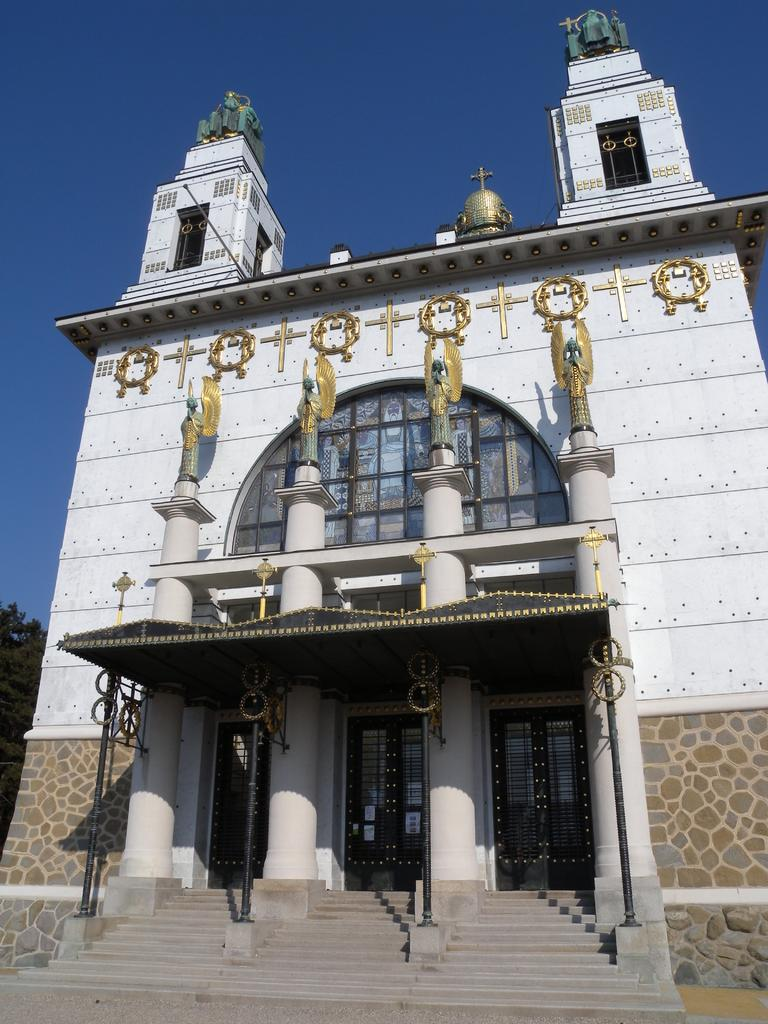What is the main structure in the center of the image? There is a building in the center of the image. What is located in front of the building? There is a tent in front of the building. What supports the tent? There are poles associated with the tent. What can be seen on the left side of the building? There is a tree on the left side of the building. What type of rose is being awarded to the person in the image? There is no person or rose present in the image. What type of badge is visible on the tree in the image? There is no badge present on the tree in the image. 